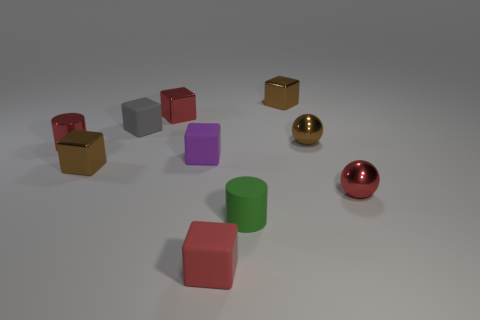Subtract all red spheres. How many brown blocks are left? 2 Subtract all red cubes. How many cubes are left? 4 Subtract all green cylinders. How many cylinders are left? 1 Subtract all balls. How many objects are left? 8 Subtract 1 cubes. How many cubes are left? 5 Add 6 brown metallic balls. How many brown metallic balls are left? 7 Add 6 small brown metal blocks. How many small brown metal blocks exist? 8 Subtract 1 red spheres. How many objects are left? 9 Subtract all purple cylinders. Subtract all red blocks. How many cylinders are left? 2 Subtract all green rubber cylinders. Subtract all tiny brown spheres. How many objects are left? 8 